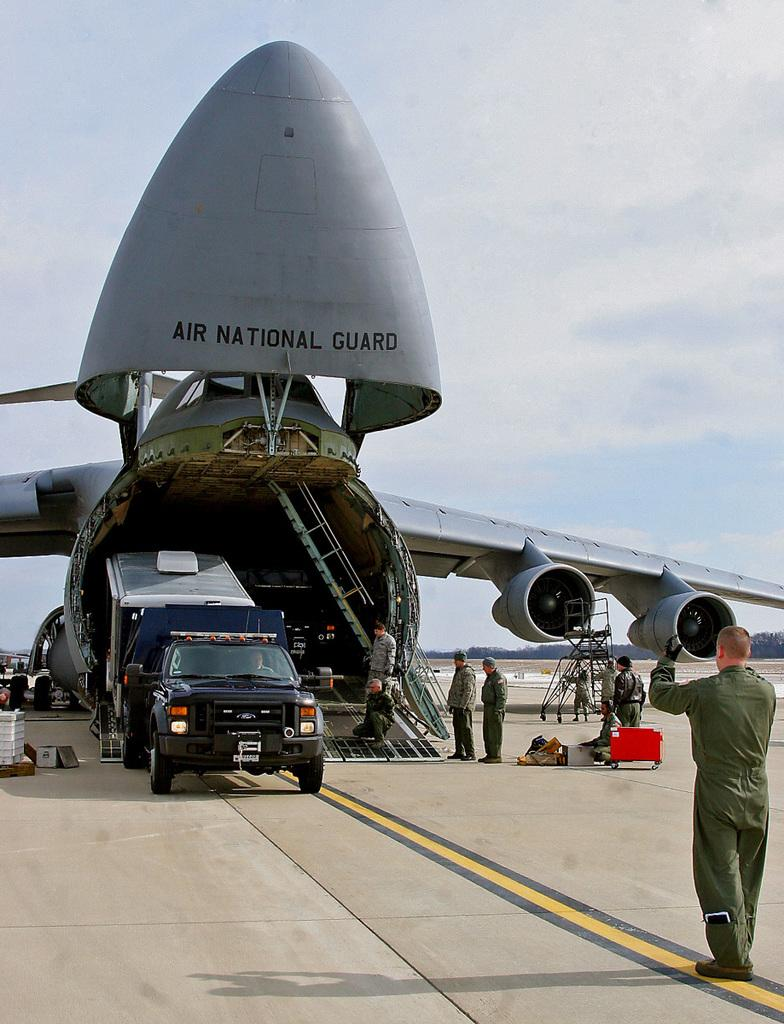Provide a one-sentence caption for the provided image. A large cargo plane belonging to the Air National Guard unloads cargo. 